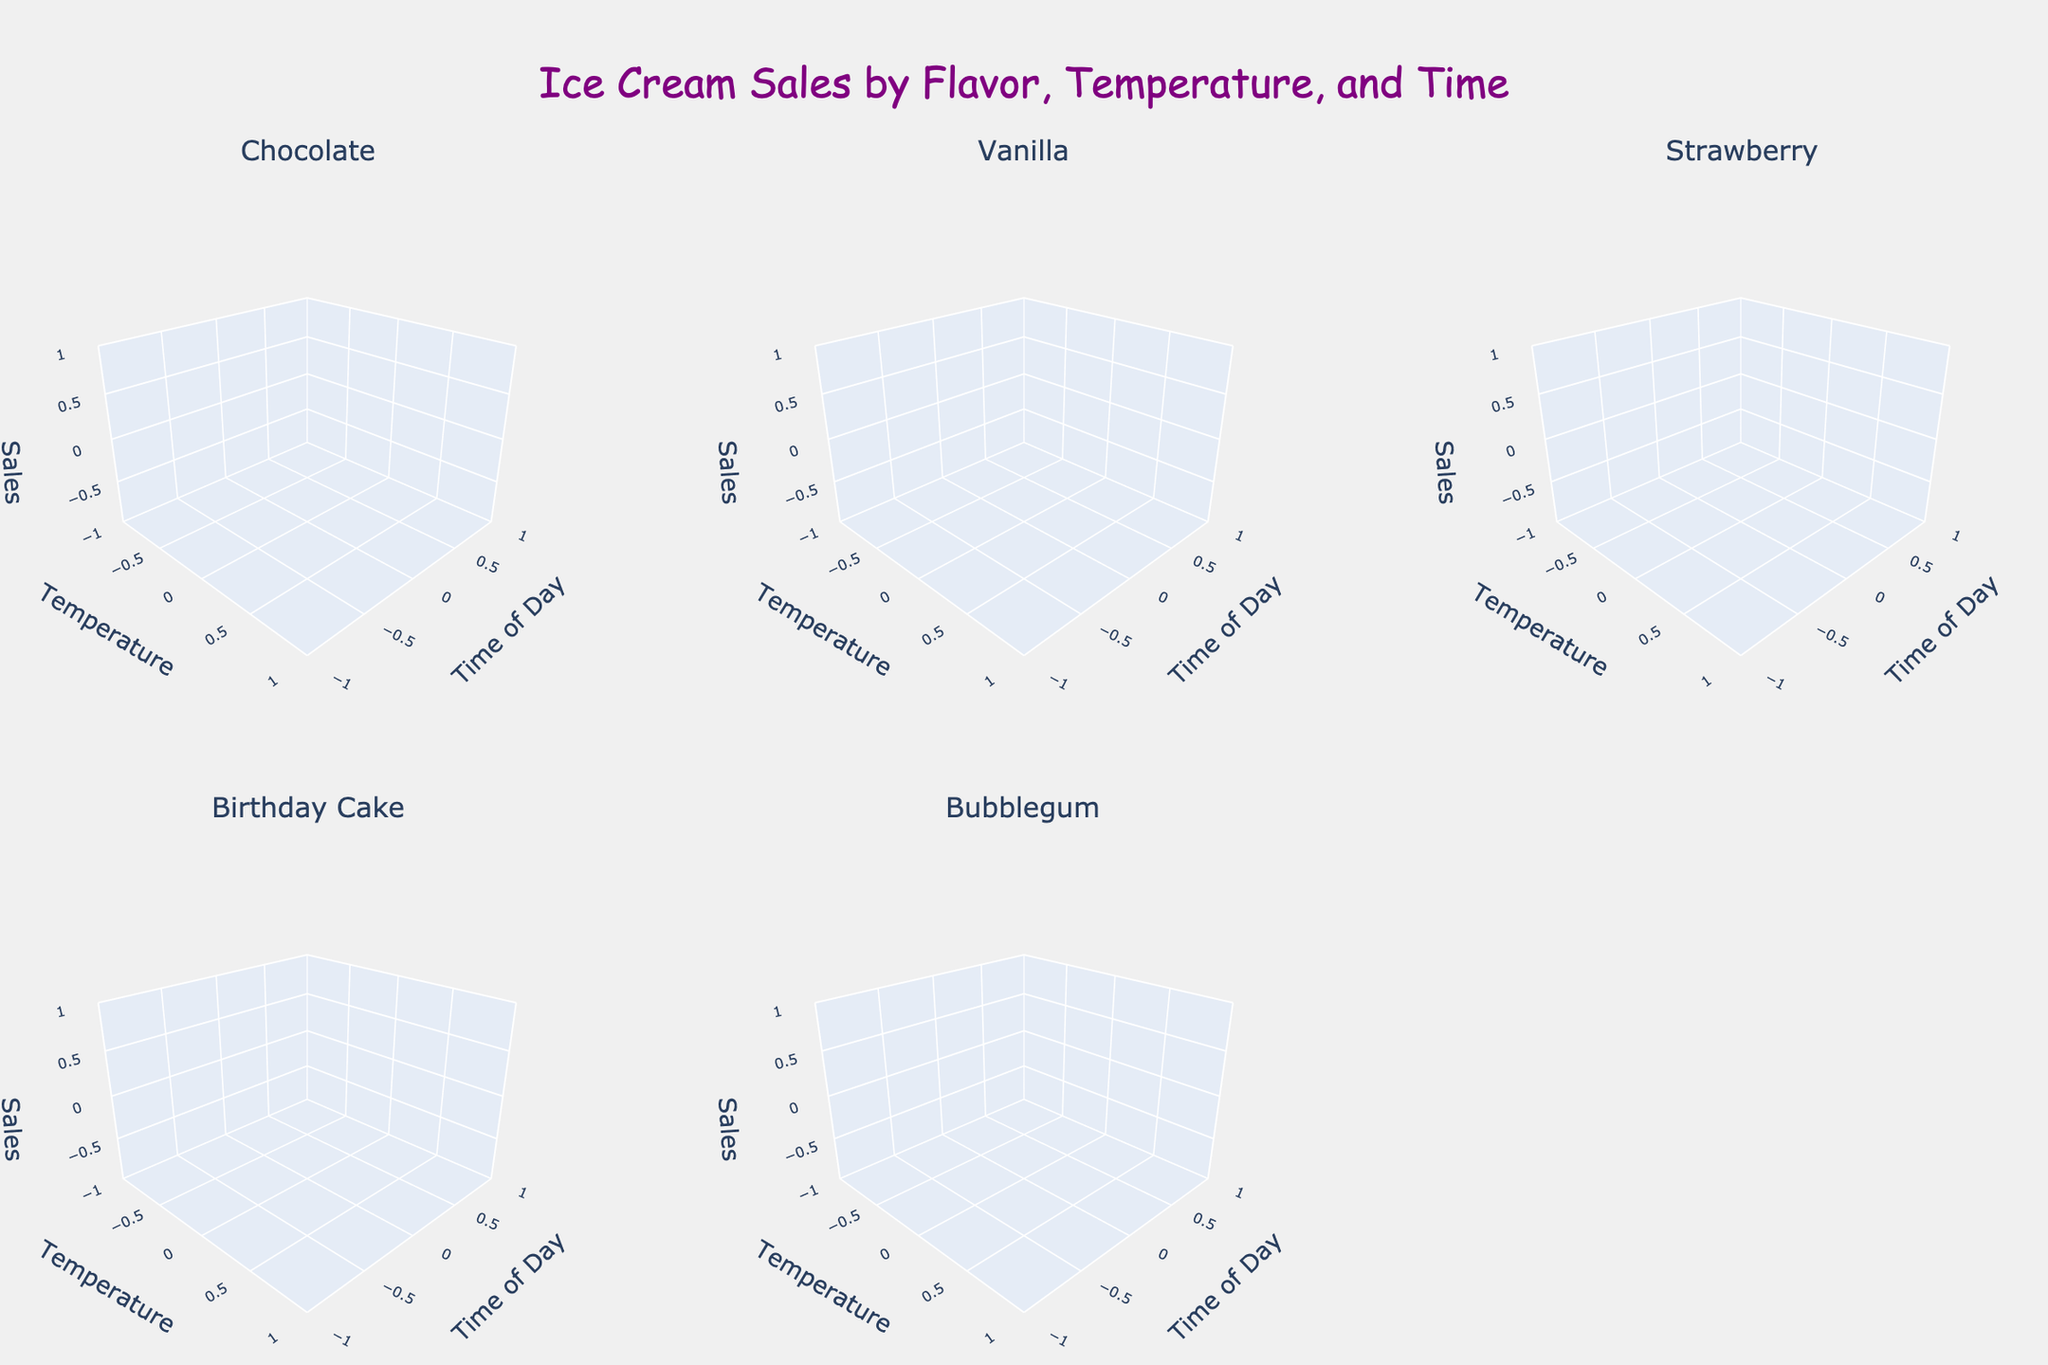What is the title of the figure? The title is usually displayed at the top of the figure. In this case, it's described at the beginning.
Answer: "Ice Cream Sales by Flavor, Temperature, and Time" How many flavors of ice cream are shown in the plot? The subplot titles indicate the number of unique flavors displayed. Counting each unique title gives the answer.
Answer: 5 Which flavor has the highest sales at the warmest temperature and the latest time? Look at the subplot for each flavor, focusing on the temperature of 85 and the time of 18. Compare the sales values.
Answer: Birthday Cake At what time of day are vanilla ice cream sales the lowest? In the Vanilla subplot, look at the sales values for each time of day and identify the lowest one.
Answer: 12:00 What is the sales volume for Bubblegum flavor when the temperature is 80 and the time is 16? In the Bubblegum subplot, locate the point where temperature is 80 and time is 16, then read off the sales volume.
Answer: 65 Compare the sales improvement of Strawberry flavor from 70°F to 85°F at 12:00 PM. Look at the Strawberry flavor subplot, find the sales values at temperature 70 and 85 for time 12:00, and calculate the difference.
Answer: 45 What is the general trend in sales for all flavors as the temperature increases? Observing all subplots, see how sales change as temperature ranges from 70 to 85. All flavors show increasing sales as temperatures rise.
Answer: Increase What is the total sales volume for Chocolate flavor across all recorded times and temperatures? Sum the sales values for Chocolate flavor at each temperature and time combination.
Answer: 290 Which flavor has the least sales increase from 75°F to 85°F? Calculate the difference in sales for each flavor at 75°F and 85°F across the times, then identify the smallest increase.
Answer: Bubblegum 